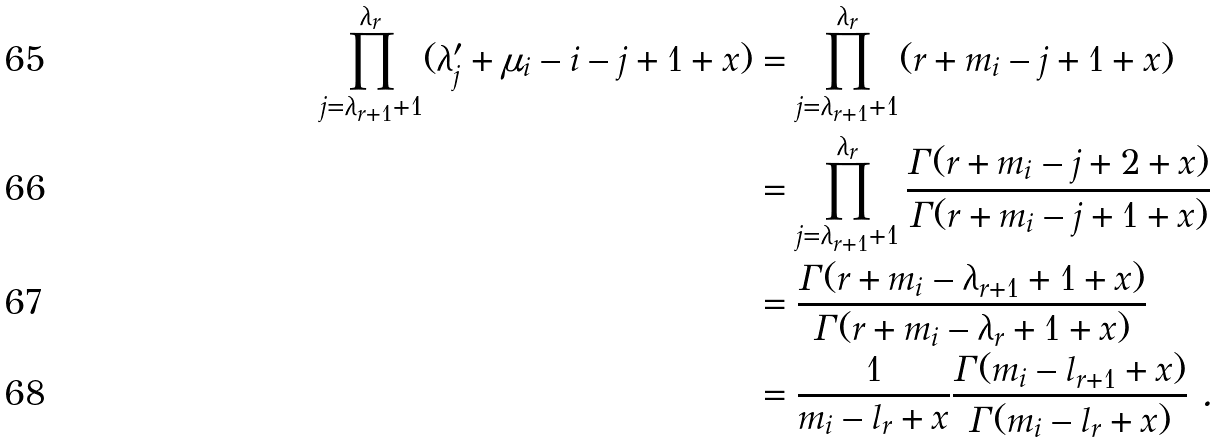<formula> <loc_0><loc_0><loc_500><loc_500>\prod _ { j = \lambda _ { r + 1 } + 1 } ^ { \lambda _ { r } } ( \lambda ^ { \prime } _ { j } + \mu _ { i } - i - j + 1 + x ) & = \prod _ { j = \lambda _ { r + 1 } + 1 } ^ { \lambda _ { r } } ( r + m _ { i } - j + 1 + x ) \\ & = \prod _ { j = \lambda _ { r + 1 } + 1 } ^ { \lambda _ { r } } \frac { \Gamma ( r + m _ { i } - j + 2 + x ) } { \Gamma ( r + m _ { i } - j + 1 + x ) } \\ & = \frac { \Gamma ( r + m _ { i } - \lambda _ { r + 1 } + 1 + x ) } { \Gamma ( r + m _ { i } - \lambda _ { r } + 1 + x ) } \\ & = \frac { 1 } { m _ { i } - l _ { r } + x } \frac { \Gamma ( m _ { i } - l _ { r + 1 } + x ) } { \Gamma ( m _ { i } - l _ { r } + x ) } \ .</formula> 